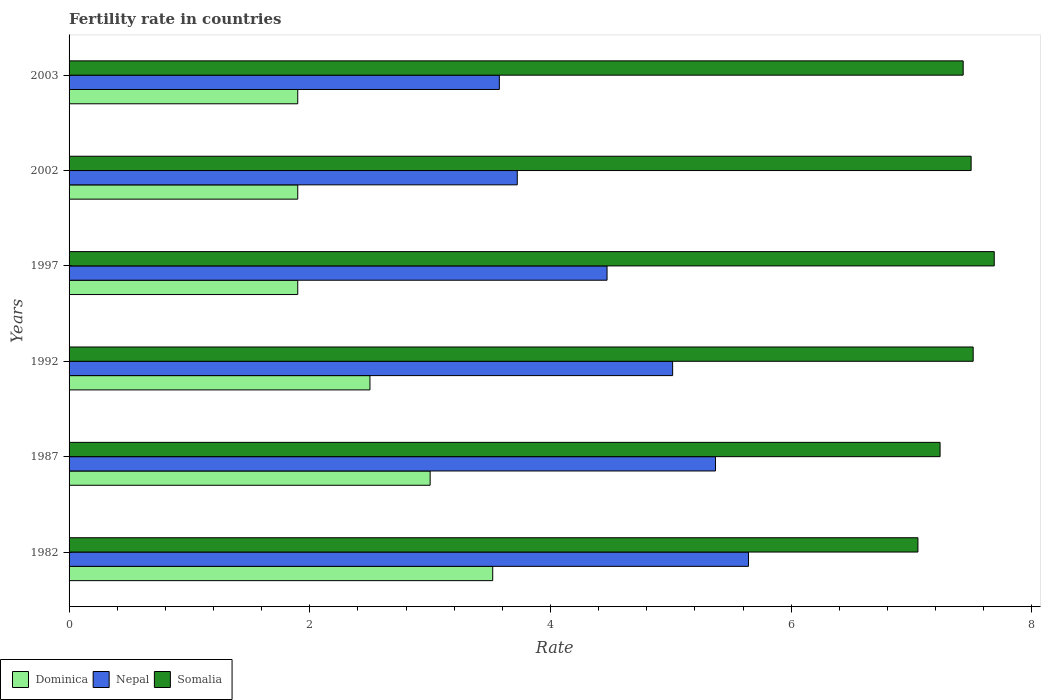How many different coloured bars are there?
Provide a succinct answer. 3. How many groups of bars are there?
Offer a very short reply. 6. How many bars are there on the 1st tick from the top?
Your answer should be compact. 3. How many bars are there on the 4th tick from the bottom?
Provide a short and direct response. 3. What is the label of the 1st group of bars from the top?
Provide a succinct answer. 2003. What is the fertility rate in Somalia in 1982?
Give a very brief answer. 7.05. Across all years, what is the maximum fertility rate in Nepal?
Give a very brief answer. 5.64. Across all years, what is the minimum fertility rate in Dominica?
Provide a short and direct response. 1.9. In which year was the fertility rate in Nepal maximum?
Make the answer very short. 1982. In which year was the fertility rate in Nepal minimum?
Give a very brief answer. 2003. What is the total fertility rate in Nepal in the graph?
Your answer should be compact. 27.8. What is the difference between the fertility rate in Dominica in 1987 and that in 2002?
Ensure brevity in your answer.  1.1. What is the difference between the fertility rate in Dominica in 1987 and the fertility rate in Nepal in 1997?
Offer a terse response. -1.47. What is the average fertility rate in Dominica per year?
Offer a very short reply. 2.45. In the year 1992, what is the difference between the fertility rate in Dominica and fertility rate in Somalia?
Your answer should be very brief. -5.01. What is the ratio of the fertility rate in Nepal in 1987 to that in 2002?
Make the answer very short. 1.44. What is the difference between the highest and the second highest fertility rate in Dominica?
Ensure brevity in your answer.  0.52. What is the difference between the highest and the lowest fertility rate in Dominica?
Your answer should be compact. 1.62. What does the 3rd bar from the top in 1982 represents?
Give a very brief answer. Dominica. What does the 2nd bar from the bottom in 2002 represents?
Offer a terse response. Nepal. Is it the case that in every year, the sum of the fertility rate in Nepal and fertility rate in Dominica is greater than the fertility rate in Somalia?
Offer a terse response. No. How many bars are there?
Ensure brevity in your answer.  18. Are all the bars in the graph horizontal?
Offer a very short reply. Yes. Are the values on the major ticks of X-axis written in scientific E-notation?
Make the answer very short. No. Does the graph contain grids?
Offer a very short reply. No. Where does the legend appear in the graph?
Provide a succinct answer. Bottom left. How are the legend labels stacked?
Keep it short and to the point. Horizontal. What is the title of the graph?
Give a very brief answer. Fertility rate in countries. Does "Gambia, The" appear as one of the legend labels in the graph?
Your answer should be very brief. No. What is the label or title of the X-axis?
Give a very brief answer. Rate. What is the label or title of the Y-axis?
Your answer should be very brief. Years. What is the Rate of Dominica in 1982?
Your response must be concise. 3.52. What is the Rate of Nepal in 1982?
Your answer should be very brief. 5.64. What is the Rate of Somalia in 1982?
Make the answer very short. 7.05. What is the Rate in Nepal in 1987?
Offer a very short reply. 5.37. What is the Rate in Somalia in 1987?
Provide a succinct answer. 7.24. What is the Rate in Dominica in 1992?
Ensure brevity in your answer.  2.5. What is the Rate in Nepal in 1992?
Give a very brief answer. 5.01. What is the Rate of Somalia in 1992?
Your response must be concise. 7.51. What is the Rate of Dominica in 1997?
Your response must be concise. 1.9. What is the Rate in Nepal in 1997?
Offer a very short reply. 4.47. What is the Rate of Somalia in 1997?
Provide a short and direct response. 7.69. What is the Rate of Nepal in 2002?
Ensure brevity in your answer.  3.72. What is the Rate in Somalia in 2002?
Ensure brevity in your answer.  7.5. What is the Rate in Nepal in 2003?
Offer a terse response. 3.58. What is the Rate of Somalia in 2003?
Your answer should be compact. 7.43. Across all years, what is the maximum Rate in Dominica?
Make the answer very short. 3.52. Across all years, what is the maximum Rate of Nepal?
Your answer should be compact. 5.64. Across all years, what is the maximum Rate in Somalia?
Provide a short and direct response. 7.69. Across all years, what is the minimum Rate in Nepal?
Offer a very short reply. 3.58. Across all years, what is the minimum Rate of Somalia?
Give a very brief answer. 7.05. What is the total Rate of Dominica in the graph?
Your answer should be very brief. 14.72. What is the total Rate of Nepal in the graph?
Give a very brief answer. 27.8. What is the total Rate of Somalia in the graph?
Make the answer very short. 44.41. What is the difference between the Rate of Dominica in 1982 and that in 1987?
Give a very brief answer. 0.52. What is the difference between the Rate in Nepal in 1982 and that in 1987?
Provide a short and direct response. 0.27. What is the difference between the Rate in Somalia in 1982 and that in 1987?
Offer a very short reply. -0.18. What is the difference between the Rate in Dominica in 1982 and that in 1992?
Your response must be concise. 1.02. What is the difference between the Rate in Nepal in 1982 and that in 1992?
Offer a very short reply. 0.63. What is the difference between the Rate of Somalia in 1982 and that in 1992?
Keep it short and to the point. -0.46. What is the difference between the Rate in Dominica in 1982 and that in 1997?
Your answer should be compact. 1.62. What is the difference between the Rate in Nepal in 1982 and that in 1997?
Ensure brevity in your answer.  1.18. What is the difference between the Rate in Somalia in 1982 and that in 1997?
Keep it short and to the point. -0.63. What is the difference between the Rate of Dominica in 1982 and that in 2002?
Provide a short and direct response. 1.62. What is the difference between the Rate of Nepal in 1982 and that in 2002?
Provide a succinct answer. 1.92. What is the difference between the Rate of Somalia in 1982 and that in 2002?
Offer a terse response. -0.44. What is the difference between the Rate in Dominica in 1982 and that in 2003?
Your answer should be very brief. 1.62. What is the difference between the Rate of Nepal in 1982 and that in 2003?
Offer a very short reply. 2.07. What is the difference between the Rate of Somalia in 1982 and that in 2003?
Your answer should be compact. -0.38. What is the difference between the Rate in Nepal in 1987 and that in 1992?
Keep it short and to the point. 0.36. What is the difference between the Rate in Somalia in 1987 and that in 1992?
Make the answer very short. -0.28. What is the difference between the Rate of Dominica in 1987 and that in 1997?
Your answer should be very brief. 1.1. What is the difference between the Rate in Nepal in 1987 and that in 1997?
Provide a succinct answer. 0.9. What is the difference between the Rate of Somalia in 1987 and that in 1997?
Ensure brevity in your answer.  -0.45. What is the difference between the Rate of Dominica in 1987 and that in 2002?
Ensure brevity in your answer.  1.1. What is the difference between the Rate of Nepal in 1987 and that in 2002?
Make the answer very short. 1.65. What is the difference between the Rate in Somalia in 1987 and that in 2002?
Your answer should be compact. -0.26. What is the difference between the Rate in Dominica in 1987 and that in 2003?
Make the answer very short. 1.1. What is the difference between the Rate in Nepal in 1987 and that in 2003?
Provide a short and direct response. 1.8. What is the difference between the Rate of Somalia in 1987 and that in 2003?
Give a very brief answer. -0.19. What is the difference between the Rate of Nepal in 1992 and that in 1997?
Your response must be concise. 0.55. What is the difference between the Rate in Somalia in 1992 and that in 1997?
Ensure brevity in your answer.  -0.17. What is the difference between the Rate of Dominica in 1992 and that in 2002?
Offer a very short reply. 0.6. What is the difference between the Rate of Nepal in 1992 and that in 2002?
Your response must be concise. 1.29. What is the difference between the Rate of Somalia in 1992 and that in 2002?
Your answer should be compact. 0.02. What is the difference between the Rate of Nepal in 1992 and that in 2003?
Give a very brief answer. 1.44. What is the difference between the Rate of Somalia in 1992 and that in 2003?
Make the answer very short. 0.08. What is the difference between the Rate in Dominica in 1997 and that in 2002?
Offer a very short reply. 0. What is the difference between the Rate in Nepal in 1997 and that in 2002?
Provide a short and direct response. 0.75. What is the difference between the Rate in Somalia in 1997 and that in 2002?
Your answer should be very brief. 0.19. What is the difference between the Rate of Dominica in 1997 and that in 2003?
Your response must be concise. 0. What is the difference between the Rate of Nepal in 1997 and that in 2003?
Your answer should be very brief. 0.9. What is the difference between the Rate of Somalia in 1997 and that in 2003?
Give a very brief answer. 0.26. What is the difference between the Rate in Dominica in 2002 and that in 2003?
Provide a short and direct response. 0. What is the difference between the Rate of Nepal in 2002 and that in 2003?
Provide a succinct answer. 0.15. What is the difference between the Rate of Somalia in 2002 and that in 2003?
Offer a terse response. 0.07. What is the difference between the Rate of Dominica in 1982 and the Rate of Nepal in 1987?
Make the answer very short. -1.85. What is the difference between the Rate in Dominica in 1982 and the Rate in Somalia in 1987?
Provide a short and direct response. -3.72. What is the difference between the Rate of Nepal in 1982 and the Rate of Somalia in 1987?
Provide a short and direct response. -1.59. What is the difference between the Rate in Dominica in 1982 and the Rate in Nepal in 1992?
Provide a succinct answer. -1.5. What is the difference between the Rate in Dominica in 1982 and the Rate in Somalia in 1992?
Your answer should be compact. -3.99. What is the difference between the Rate of Nepal in 1982 and the Rate of Somalia in 1992?
Give a very brief answer. -1.87. What is the difference between the Rate of Dominica in 1982 and the Rate of Nepal in 1997?
Provide a short and direct response. -0.95. What is the difference between the Rate in Dominica in 1982 and the Rate in Somalia in 1997?
Provide a short and direct response. -4.17. What is the difference between the Rate in Nepal in 1982 and the Rate in Somalia in 1997?
Your response must be concise. -2.04. What is the difference between the Rate of Dominica in 1982 and the Rate of Nepal in 2002?
Provide a succinct answer. -0.2. What is the difference between the Rate in Dominica in 1982 and the Rate in Somalia in 2002?
Make the answer very short. -3.98. What is the difference between the Rate of Nepal in 1982 and the Rate of Somalia in 2002?
Provide a succinct answer. -1.85. What is the difference between the Rate of Dominica in 1982 and the Rate of Nepal in 2003?
Your answer should be compact. -0.06. What is the difference between the Rate of Dominica in 1982 and the Rate of Somalia in 2003?
Provide a short and direct response. -3.91. What is the difference between the Rate in Nepal in 1982 and the Rate in Somalia in 2003?
Give a very brief answer. -1.78. What is the difference between the Rate of Dominica in 1987 and the Rate of Nepal in 1992?
Ensure brevity in your answer.  -2.02. What is the difference between the Rate in Dominica in 1987 and the Rate in Somalia in 1992?
Offer a very short reply. -4.51. What is the difference between the Rate in Nepal in 1987 and the Rate in Somalia in 1992?
Provide a short and direct response. -2.14. What is the difference between the Rate of Dominica in 1987 and the Rate of Nepal in 1997?
Give a very brief answer. -1.47. What is the difference between the Rate of Dominica in 1987 and the Rate of Somalia in 1997?
Offer a very short reply. -4.69. What is the difference between the Rate of Nepal in 1987 and the Rate of Somalia in 1997?
Give a very brief answer. -2.32. What is the difference between the Rate of Dominica in 1987 and the Rate of Nepal in 2002?
Make the answer very short. -0.72. What is the difference between the Rate in Dominica in 1987 and the Rate in Somalia in 2002?
Offer a very short reply. -4.5. What is the difference between the Rate in Nepal in 1987 and the Rate in Somalia in 2002?
Your answer should be compact. -2.12. What is the difference between the Rate in Dominica in 1987 and the Rate in Nepal in 2003?
Provide a short and direct response. -0.57. What is the difference between the Rate of Dominica in 1987 and the Rate of Somalia in 2003?
Your response must be concise. -4.43. What is the difference between the Rate of Nepal in 1987 and the Rate of Somalia in 2003?
Ensure brevity in your answer.  -2.06. What is the difference between the Rate of Dominica in 1992 and the Rate of Nepal in 1997?
Make the answer very short. -1.97. What is the difference between the Rate in Dominica in 1992 and the Rate in Somalia in 1997?
Provide a short and direct response. -5.19. What is the difference between the Rate in Nepal in 1992 and the Rate in Somalia in 1997?
Provide a short and direct response. -2.67. What is the difference between the Rate of Dominica in 1992 and the Rate of Nepal in 2002?
Offer a very short reply. -1.22. What is the difference between the Rate of Dominica in 1992 and the Rate of Somalia in 2002?
Your response must be concise. -5. What is the difference between the Rate in Nepal in 1992 and the Rate in Somalia in 2002?
Keep it short and to the point. -2.48. What is the difference between the Rate of Dominica in 1992 and the Rate of Nepal in 2003?
Provide a succinct answer. -1.07. What is the difference between the Rate of Dominica in 1992 and the Rate of Somalia in 2003?
Provide a succinct answer. -4.93. What is the difference between the Rate of Nepal in 1992 and the Rate of Somalia in 2003?
Make the answer very short. -2.41. What is the difference between the Rate of Dominica in 1997 and the Rate of Nepal in 2002?
Provide a short and direct response. -1.82. What is the difference between the Rate of Dominica in 1997 and the Rate of Somalia in 2002?
Your answer should be compact. -5.59. What is the difference between the Rate in Nepal in 1997 and the Rate in Somalia in 2002?
Offer a terse response. -3.02. What is the difference between the Rate of Dominica in 1997 and the Rate of Nepal in 2003?
Your answer should be compact. -1.68. What is the difference between the Rate in Dominica in 1997 and the Rate in Somalia in 2003?
Give a very brief answer. -5.53. What is the difference between the Rate of Nepal in 1997 and the Rate of Somalia in 2003?
Give a very brief answer. -2.96. What is the difference between the Rate of Dominica in 2002 and the Rate of Nepal in 2003?
Make the answer very short. -1.68. What is the difference between the Rate in Dominica in 2002 and the Rate in Somalia in 2003?
Give a very brief answer. -5.53. What is the difference between the Rate in Nepal in 2002 and the Rate in Somalia in 2003?
Offer a terse response. -3.71. What is the average Rate of Dominica per year?
Ensure brevity in your answer.  2.45. What is the average Rate in Nepal per year?
Offer a terse response. 4.63. What is the average Rate in Somalia per year?
Offer a terse response. 7.4. In the year 1982, what is the difference between the Rate of Dominica and Rate of Nepal?
Ensure brevity in your answer.  -2.12. In the year 1982, what is the difference between the Rate in Dominica and Rate in Somalia?
Your answer should be compact. -3.53. In the year 1982, what is the difference between the Rate of Nepal and Rate of Somalia?
Provide a short and direct response. -1.41. In the year 1987, what is the difference between the Rate in Dominica and Rate in Nepal?
Make the answer very short. -2.37. In the year 1987, what is the difference between the Rate of Dominica and Rate of Somalia?
Your answer should be compact. -4.24. In the year 1987, what is the difference between the Rate in Nepal and Rate in Somalia?
Offer a terse response. -1.87. In the year 1992, what is the difference between the Rate in Dominica and Rate in Nepal?
Your answer should be very brief. -2.52. In the year 1992, what is the difference between the Rate of Dominica and Rate of Somalia?
Your answer should be very brief. -5.01. In the year 1992, what is the difference between the Rate of Nepal and Rate of Somalia?
Make the answer very short. -2.5. In the year 1997, what is the difference between the Rate of Dominica and Rate of Nepal?
Your answer should be compact. -2.57. In the year 1997, what is the difference between the Rate of Dominica and Rate of Somalia?
Keep it short and to the point. -5.79. In the year 1997, what is the difference between the Rate in Nepal and Rate in Somalia?
Make the answer very short. -3.22. In the year 2002, what is the difference between the Rate of Dominica and Rate of Nepal?
Your response must be concise. -1.82. In the year 2002, what is the difference between the Rate in Dominica and Rate in Somalia?
Keep it short and to the point. -5.59. In the year 2002, what is the difference between the Rate in Nepal and Rate in Somalia?
Your answer should be very brief. -3.77. In the year 2003, what is the difference between the Rate in Dominica and Rate in Nepal?
Your answer should be very brief. -1.68. In the year 2003, what is the difference between the Rate in Dominica and Rate in Somalia?
Keep it short and to the point. -5.53. In the year 2003, what is the difference between the Rate of Nepal and Rate of Somalia?
Offer a very short reply. -3.85. What is the ratio of the Rate of Dominica in 1982 to that in 1987?
Your answer should be compact. 1.17. What is the ratio of the Rate in Nepal in 1982 to that in 1987?
Offer a terse response. 1.05. What is the ratio of the Rate in Somalia in 1982 to that in 1987?
Provide a short and direct response. 0.97. What is the ratio of the Rate of Dominica in 1982 to that in 1992?
Offer a very short reply. 1.41. What is the ratio of the Rate in Nepal in 1982 to that in 1992?
Ensure brevity in your answer.  1.13. What is the ratio of the Rate of Somalia in 1982 to that in 1992?
Offer a very short reply. 0.94. What is the ratio of the Rate in Dominica in 1982 to that in 1997?
Offer a terse response. 1.85. What is the ratio of the Rate in Nepal in 1982 to that in 1997?
Ensure brevity in your answer.  1.26. What is the ratio of the Rate in Somalia in 1982 to that in 1997?
Ensure brevity in your answer.  0.92. What is the ratio of the Rate of Dominica in 1982 to that in 2002?
Provide a succinct answer. 1.85. What is the ratio of the Rate of Nepal in 1982 to that in 2002?
Provide a short and direct response. 1.52. What is the ratio of the Rate of Somalia in 1982 to that in 2002?
Your answer should be very brief. 0.94. What is the ratio of the Rate in Dominica in 1982 to that in 2003?
Your answer should be compact. 1.85. What is the ratio of the Rate in Nepal in 1982 to that in 2003?
Ensure brevity in your answer.  1.58. What is the ratio of the Rate of Somalia in 1982 to that in 2003?
Give a very brief answer. 0.95. What is the ratio of the Rate in Dominica in 1987 to that in 1992?
Offer a very short reply. 1.2. What is the ratio of the Rate in Nepal in 1987 to that in 1992?
Your answer should be very brief. 1.07. What is the ratio of the Rate in Somalia in 1987 to that in 1992?
Provide a succinct answer. 0.96. What is the ratio of the Rate of Dominica in 1987 to that in 1997?
Your answer should be very brief. 1.58. What is the ratio of the Rate in Nepal in 1987 to that in 1997?
Your response must be concise. 1.2. What is the ratio of the Rate of Somalia in 1987 to that in 1997?
Keep it short and to the point. 0.94. What is the ratio of the Rate of Dominica in 1987 to that in 2002?
Offer a terse response. 1.58. What is the ratio of the Rate of Nepal in 1987 to that in 2002?
Give a very brief answer. 1.44. What is the ratio of the Rate of Somalia in 1987 to that in 2002?
Give a very brief answer. 0.97. What is the ratio of the Rate of Dominica in 1987 to that in 2003?
Provide a succinct answer. 1.58. What is the ratio of the Rate of Nepal in 1987 to that in 2003?
Provide a short and direct response. 1.5. What is the ratio of the Rate in Somalia in 1987 to that in 2003?
Your answer should be compact. 0.97. What is the ratio of the Rate in Dominica in 1992 to that in 1997?
Your answer should be compact. 1.32. What is the ratio of the Rate in Nepal in 1992 to that in 1997?
Your answer should be very brief. 1.12. What is the ratio of the Rate of Somalia in 1992 to that in 1997?
Keep it short and to the point. 0.98. What is the ratio of the Rate of Dominica in 1992 to that in 2002?
Your answer should be very brief. 1.32. What is the ratio of the Rate of Nepal in 1992 to that in 2002?
Give a very brief answer. 1.35. What is the ratio of the Rate in Dominica in 1992 to that in 2003?
Your answer should be very brief. 1.32. What is the ratio of the Rate of Nepal in 1992 to that in 2003?
Your answer should be compact. 1.4. What is the ratio of the Rate in Somalia in 1992 to that in 2003?
Make the answer very short. 1.01. What is the ratio of the Rate of Dominica in 1997 to that in 2002?
Your answer should be very brief. 1. What is the ratio of the Rate of Nepal in 1997 to that in 2002?
Your response must be concise. 1.2. What is the ratio of the Rate in Somalia in 1997 to that in 2002?
Ensure brevity in your answer.  1.03. What is the ratio of the Rate of Dominica in 1997 to that in 2003?
Make the answer very short. 1. What is the ratio of the Rate in Nepal in 1997 to that in 2003?
Make the answer very short. 1.25. What is the ratio of the Rate in Somalia in 1997 to that in 2003?
Provide a short and direct response. 1.03. What is the ratio of the Rate of Dominica in 2002 to that in 2003?
Your answer should be very brief. 1. What is the ratio of the Rate in Nepal in 2002 to that in 2003?
Offer a terse response. 1.04. What is the ratio of the Rate in Somalia in 2002 to that in 2003?
Offer a very short reply. 1.01. What is the difference between the highest and the second highest Rate of Dominica?
Offer a very short reply. 0.52. What is the difference between the highest and the second highest Rate in Nepal?
Your answer should be very brief. 0.27. What is the difference between the highest and the second highest Rate of Somalia?
Ensure brevity in your answer.  0.17. What is the difference between the highest and the lowest Rate of Dominica?
Offer a terse response. 1.62. What is the difference between the highest and the lowest Rate of Nepal?
Your answer should be compact. 2.07. What is the difference between the highest and the lowest Rate of Somalia?
Provide a short and direct response. 0.63. 